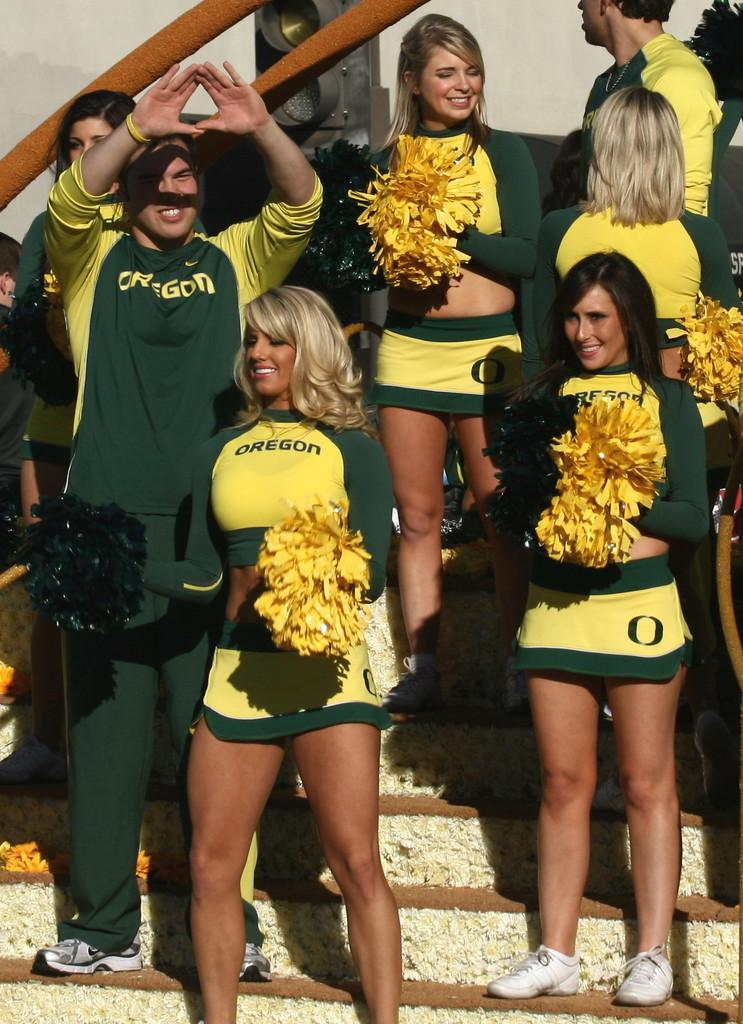<image>
Share a concise interpretation of the image provided. Male and female cheerleaders for Oregon are standing up on a set of stairs cheering. 